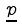<formula> <loc_0><loc_0><loc_500><loc_500>\underline { p }</formula> 